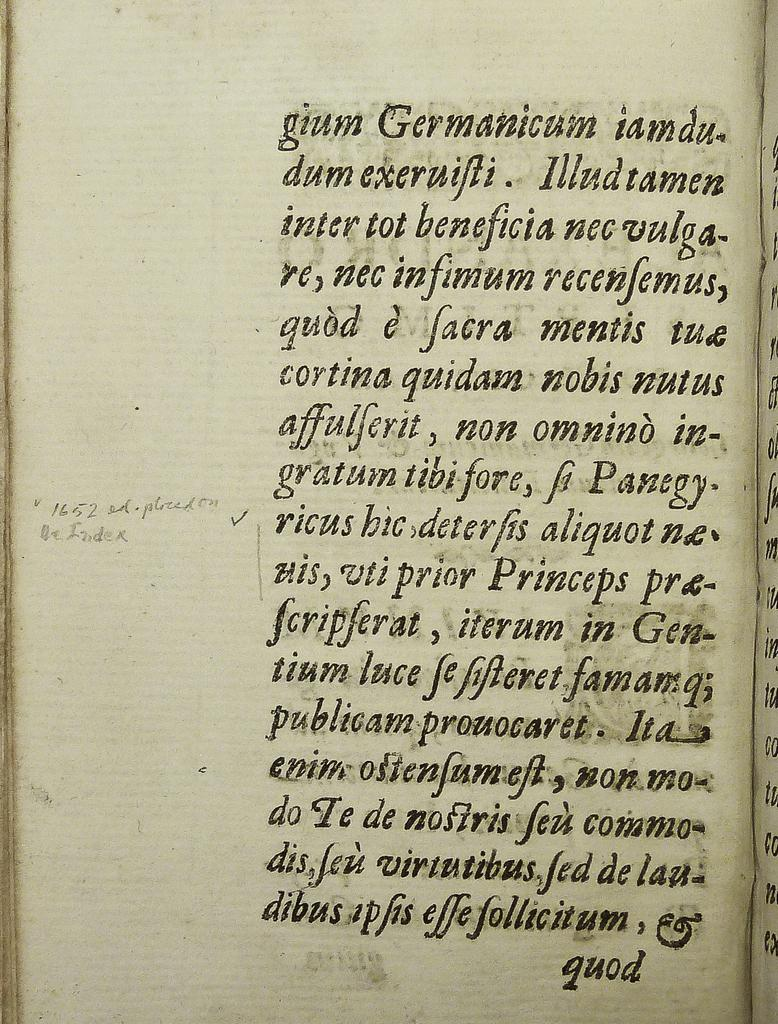What is present in the image that has text on it? There is a paper in the image that has text on it. Can you describe the text on the paper? Unfortunately, the specific content of the text cannot be determined from the image alone. What is the primary material of the paper? The paper is likely made of a thin, flexible material, such as wood pulp or recycled fibers. How many silver dimes are stacked on the paper in the image? There is no mention of silver dimes or any other objects stacked on the paper in the image. 